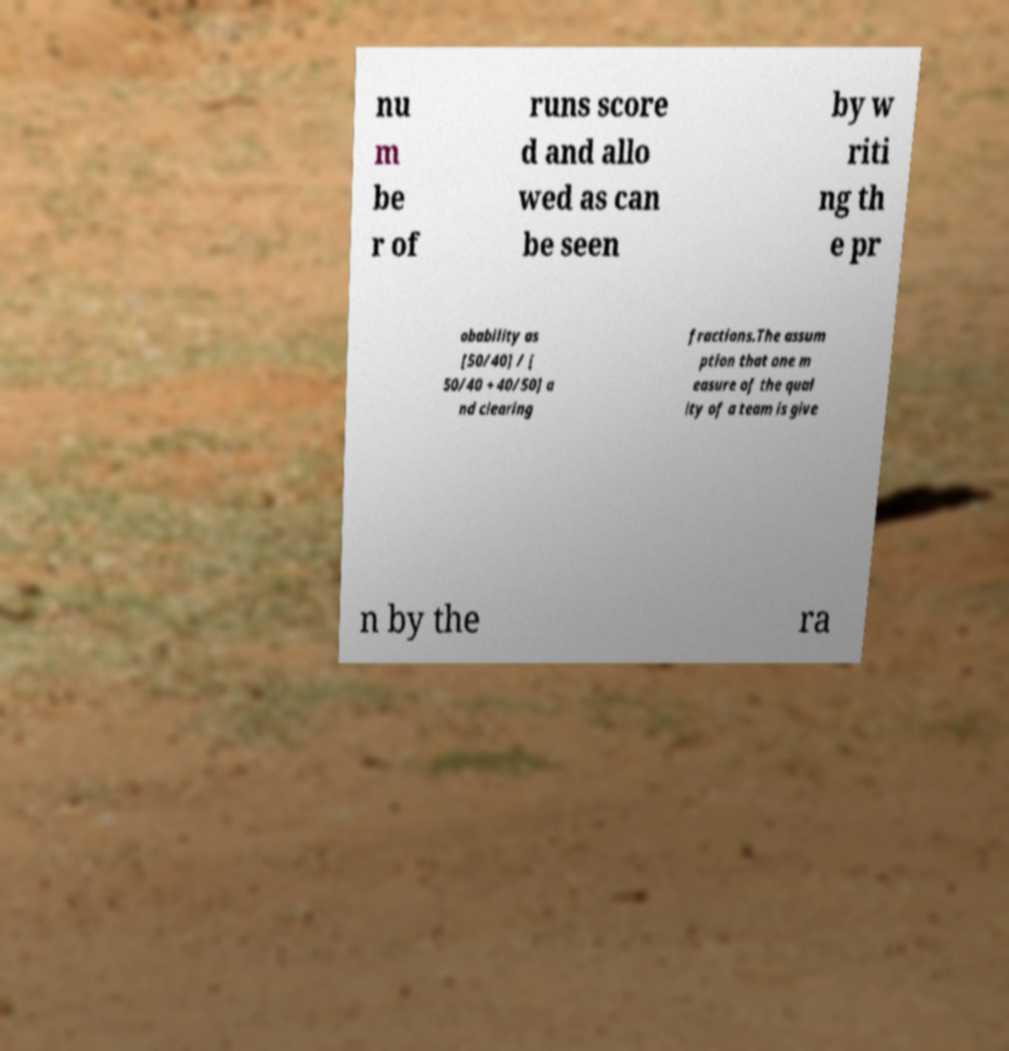What messages or text are displayed in this image? I need them in a readable, typed format. nu m be r of runs score d and allo wed as can be seen by w riti ng th e pr obability as [50/40] / [ 50/40 + 40/50] a nd clearing fractions.The assum ption that one m easure of the qual ity of a team is give n by the ra 